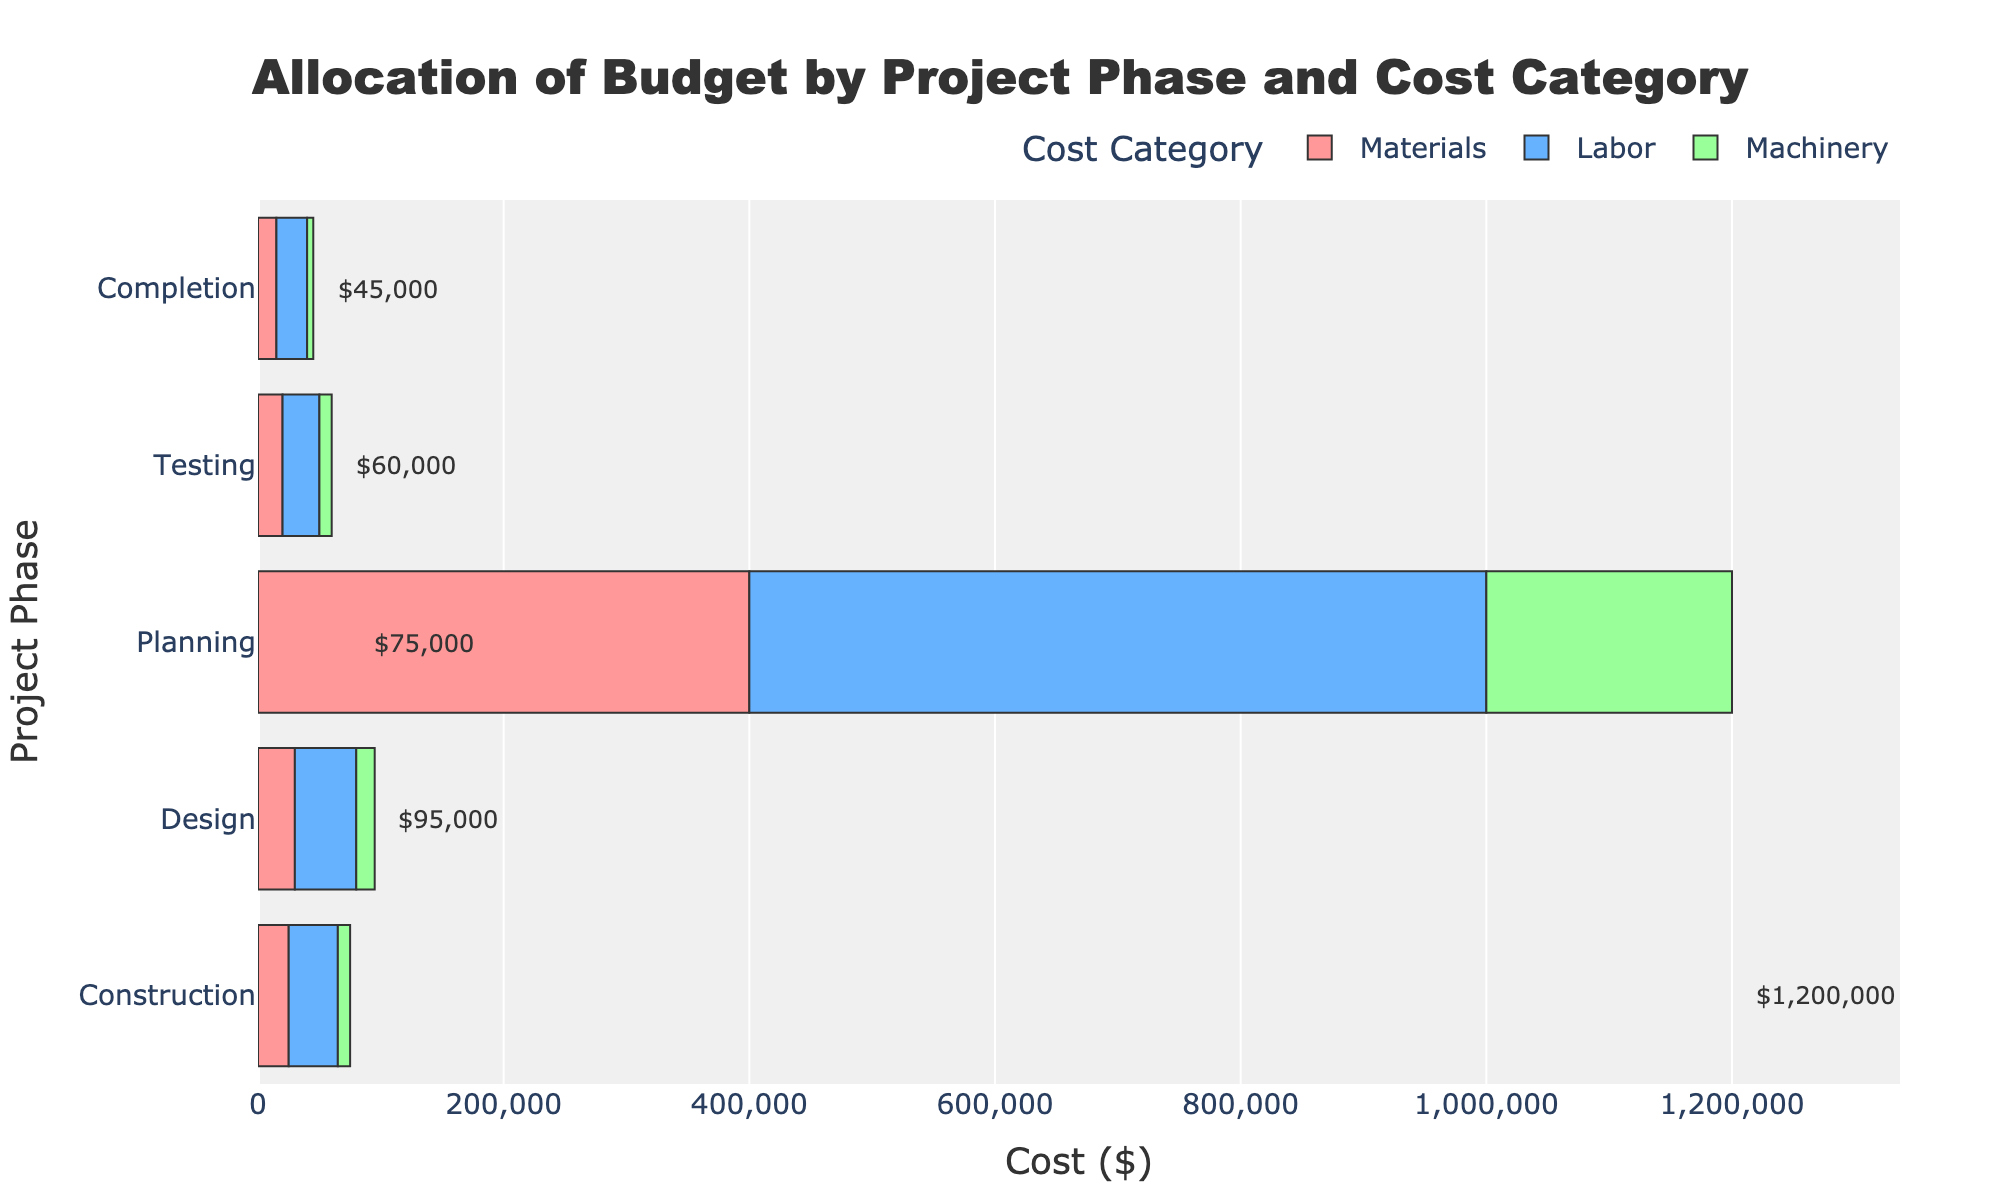What is the total cost of the Construction phase? The total cost for each phase is annotated on the chart. For the Construction phase, the annotation reads $1,200,000, reflecting the sum of Materials, Labor, and Machinery costs.
Answer: $1,200,000 Which cost category has the highest expenditure in the Design phase? By comparing the lengths of the bars for Materials, Labor, and Machinery within the Design phase, it's clear that Labor has the longest bar and thus the highest expenditure.
Answer: Labor How does the total cost of the Planning phase compare to the Completion phase? From the annotations, the total cost of the Planning phase is $75,000, and for the Completion phase, it is $45,000. Planning has a higher total cost by $30,000.
Answer: Planning is higher by $30,000 What is the difference in Labor costs between the Construction and Testing phases? Labor costs for Construction are $600,000, and for Testing, they are $30,000. Subtracting these gives $600,000 - $30,000 = $570,000.
Answer: $570,000 Which project phase has the least amount spent on Machinery? Comparing the lengths of the Machinery bars across all phases, the Machinery bar is shortest (least expenditure) in the Completion phase.
Answer: Completion What is the combined cost of Materials for both the Planning and Testing phases? Materials cost for Planning is $25,000 and for Testing is $20,000. Adding these gives $25,000 + $20,000 = $45,000.
Answer: $45,000 How much more is spent on Machinery than on Materials in the Construction phase? In the Construction phase, Machinery costs are $200,000 and Materials are $400,000. The difference is $400,000 - $200,000 = $200,000.
Answer: $200,000 more is spent on Materials Compare the total costs of the Design and Testing phases. Which one is greater? From the annotations, the total cost for the Design phase is $95,000 and for the Testing phase is $60,000. Design has the greater total cost.
Answer: Design What is the average cost of Labor across all phases? The Labor costs for all phases are $40,000, $50,000, $600,000, $30,000, and $25,000. Summing these gives $745,000. There are 5 phases, so the average is $745,000 / 5 = $149,000.
Answer: $149,000 